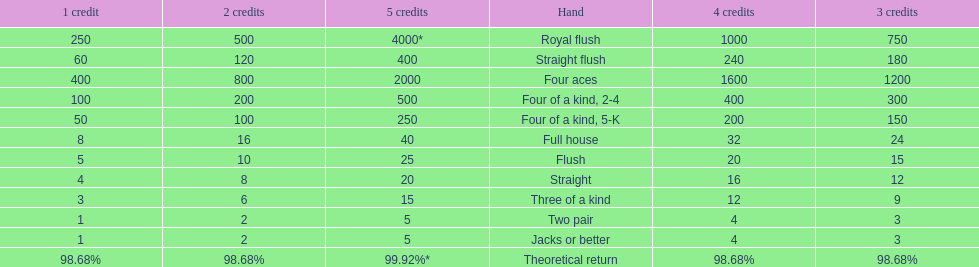What is the higher amount of points for one credit you can get from the best four of a kind 100. What type is it? Four of a kind, 2-4. 